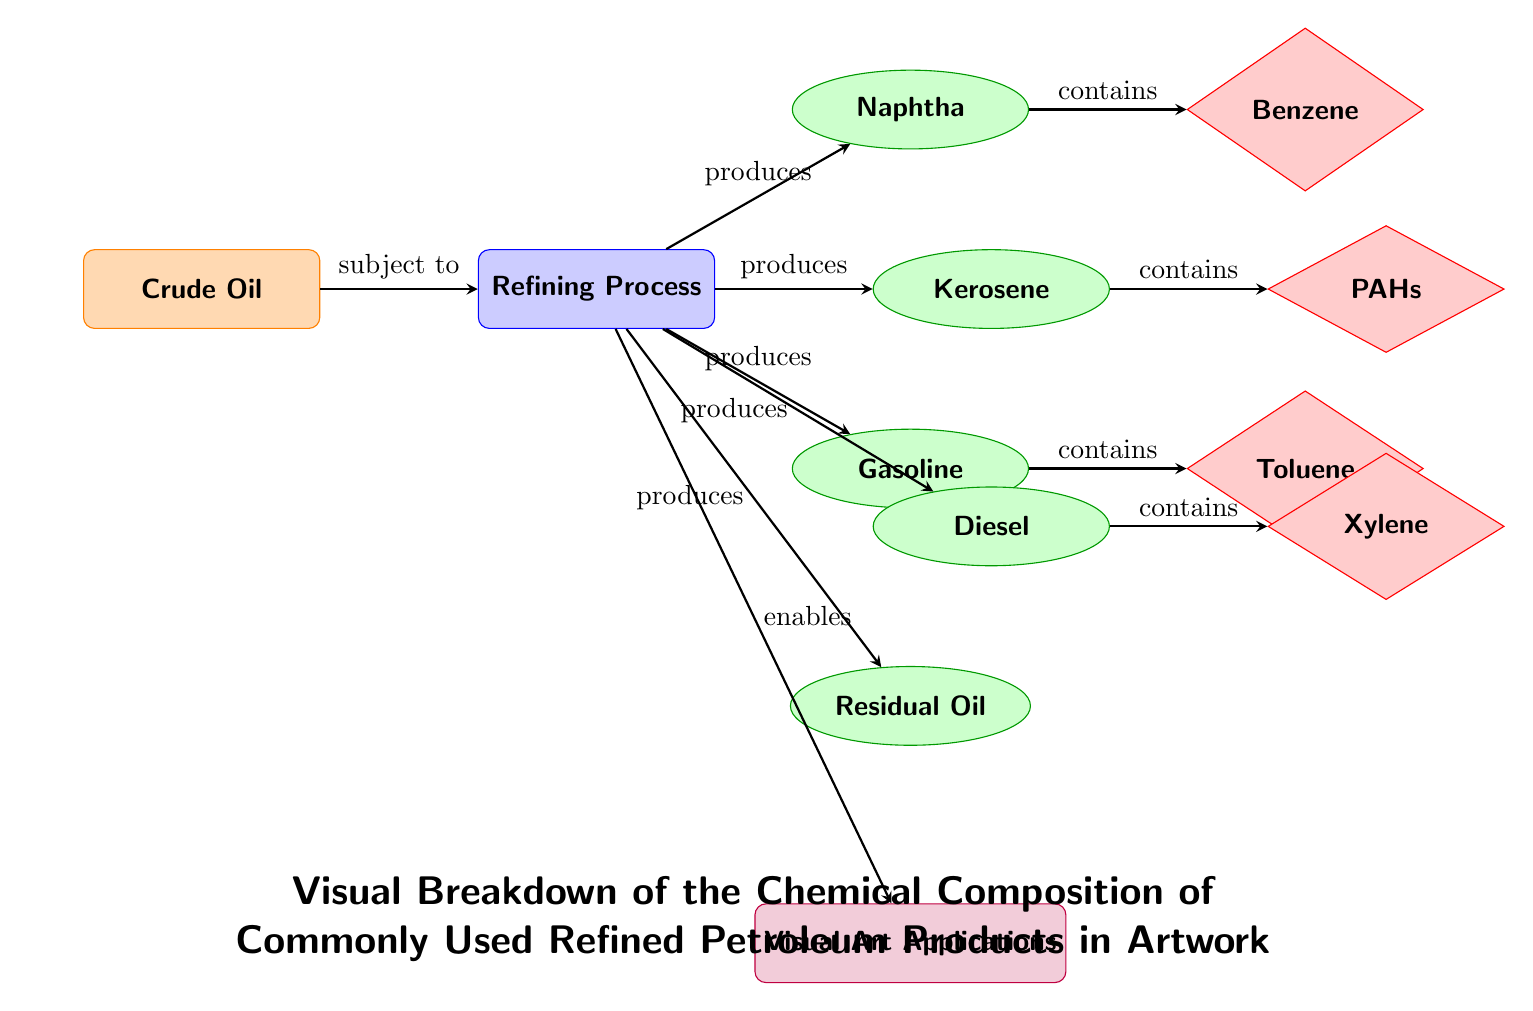What is the main resource in the diagram? The main resource is indicated at the top of the diagram; it is labeled "Crude Oil". This node serves as the starting point for the refining process in the diagram.
Answer: Crude Oil How many refined petroleum products are produced from the refining process? The refined petroleum products are clearly listed with arrows leading from the refining process node, and there are a total of five products connected.
Answer: 5 Which refined product contains Benzene? The arrow from the naphtha product indicates it contains Benzene, and this connection shows the specific chemical composition of naphtha.
Answer: Naphtha What do Kerosene and Diesel share in the diagram? Both Kerosene and Diesel are products of the refining process and are positioned below it; they also both contain compounds. Additionally, both products have arrows leading to compounds, identifying their chemical constituents.
Answer: They are both products of the refining process Which refined product is connected to the application of Visual Art? The Visual Art Applications node is connected to the refining process, indicating that all products ultimately enable visual art applications, but the residual oil is at the bottom and signifies a direct relation to potential artistic usage.
Answer: All refined products 